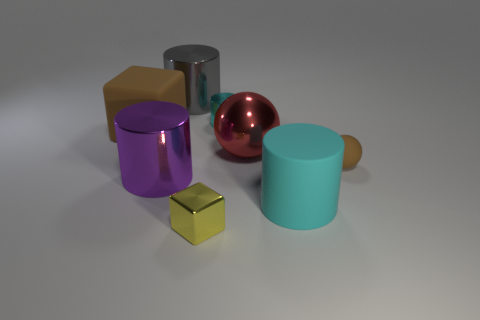Subtract all metal cylinders. How many cylinders are left? 1 Add 1 metal objects. How many objects exist? 9 Subtract 2 cylinders. How many cylinders are left? 2 Subtract all blue balls. How many cyan cylinders are left? 2 Subtract all red spheres. How many spheres are left? 1 Subtract all cubes. How many objects are left? 6 Subtract all cyan metal cylinders. Subtract all purple metallic things. How many objects are left? 6 Add 2 small cylinders. How many small cylinders are left? 3 Add 2 big rubber cylinders. How many big rubber cylinders exist? 3 Subtract 0 green cubes. How many objects are left? 8 